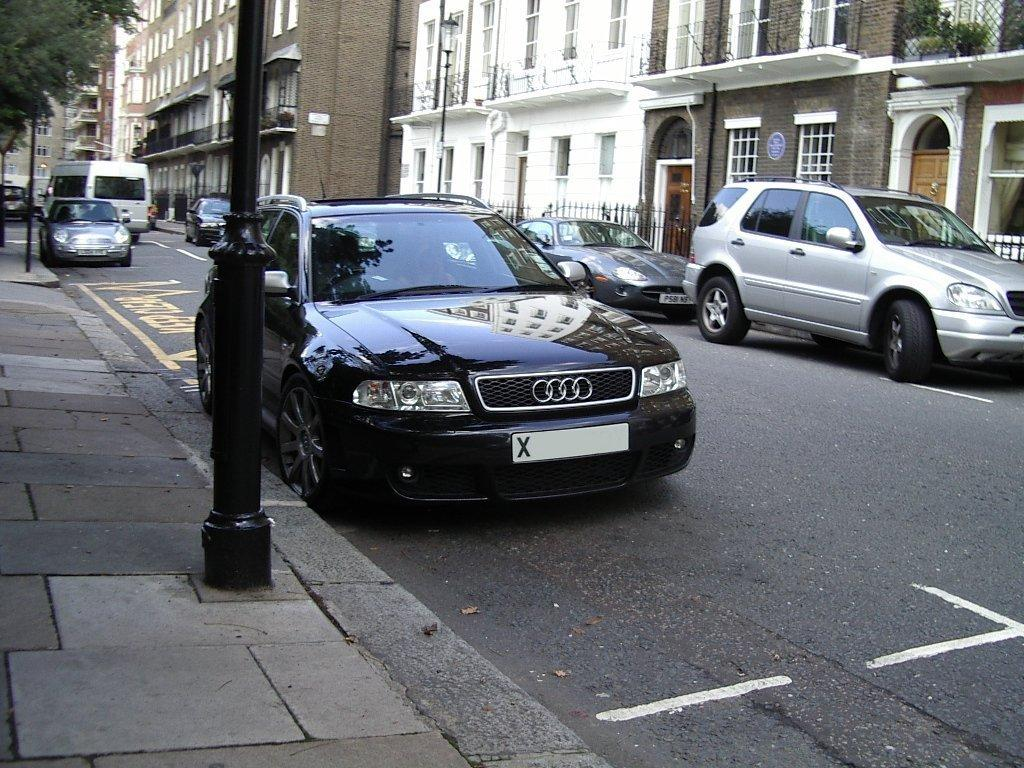What can be seen on the road in the image? There are vehicles on the road in the image. What is visible in the background of the image? There are buildings and trees in the background of the image. What structures are present in the image? There are poles in the image. What type of path is visible in the image? There is a sidewalk in the image. What objects are visible on the sidewalk? There are grills visible in the image. Can you see any cherries growing on the trees in the image? There is no mention of cherries or trees with fruit in the provided facts, so we cannot determine if cherries are present in the image. Is the seashore visible in the image? The provided facts mention buildings and trees in the background, but there is no mention of a seashore, so we cannot determine if it is visible in the image. 